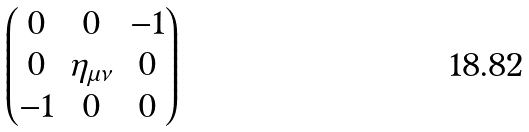Convert formula to latex. <formula><loc_0><loc_0><loc_500><loc_500>\begin{pmatrix} 0 & 0 & - 1 \\ 0 & \eta _ { \mu \nu } & 0 \\ - 1 & 0 & 0 \end{pmatrix}</formula> 